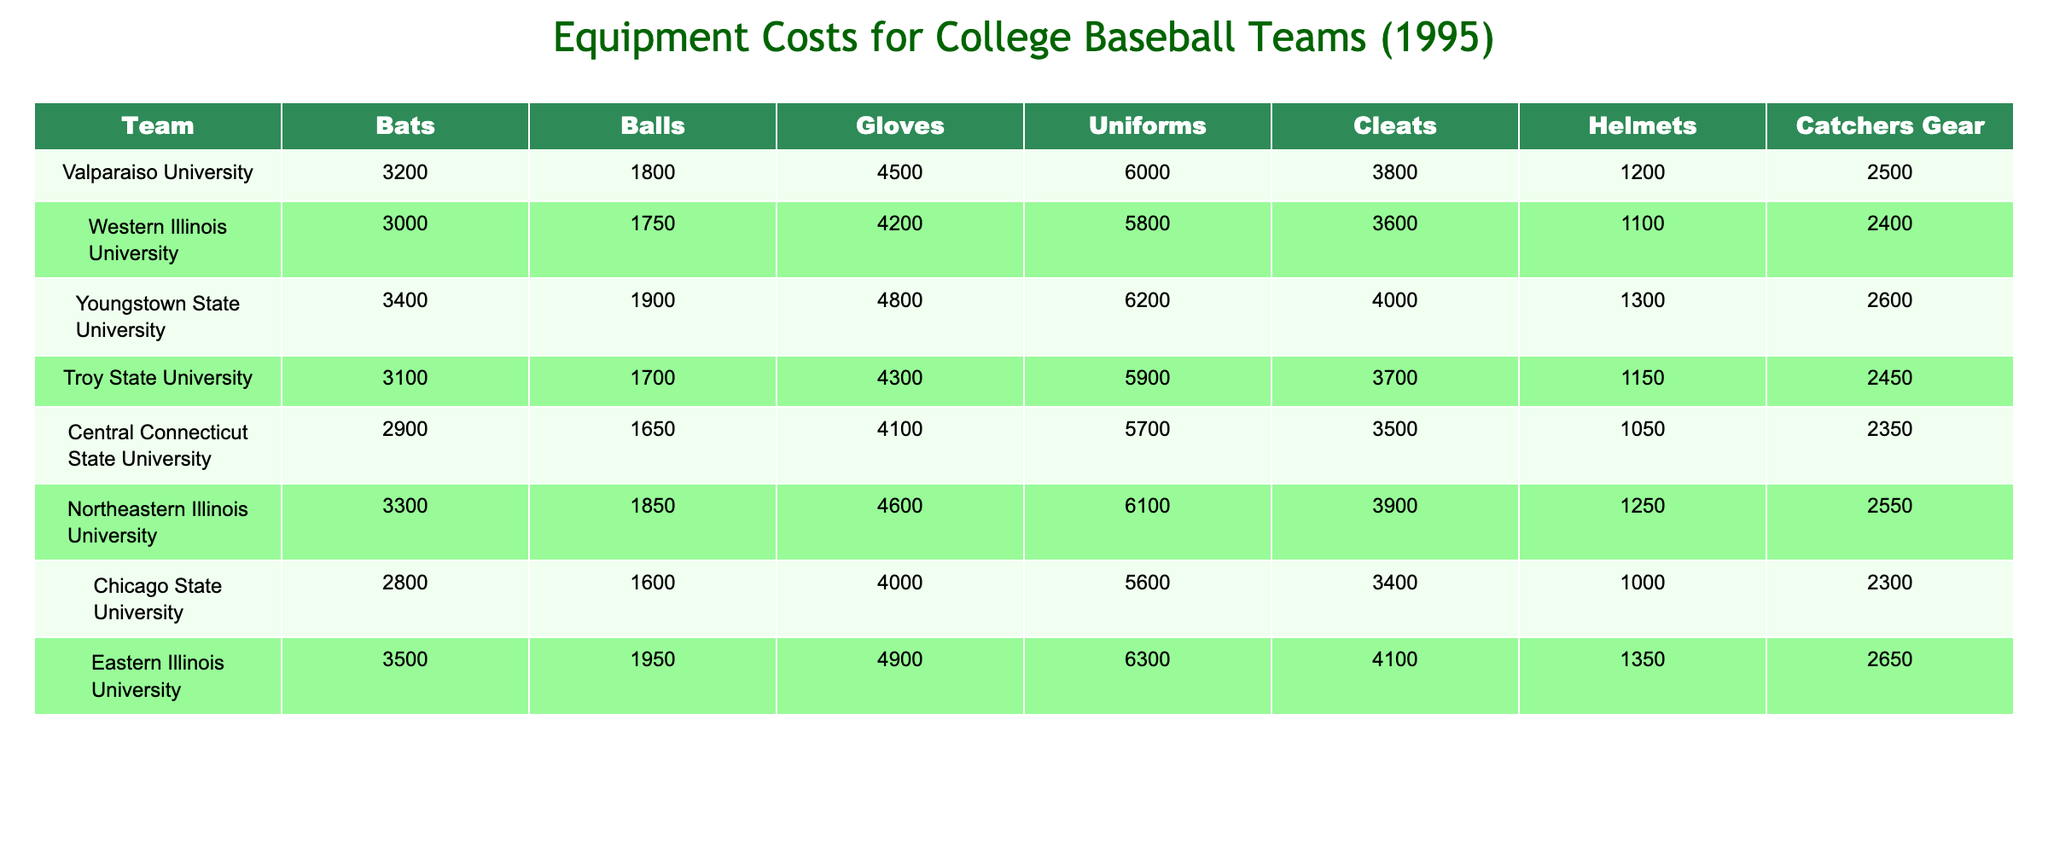What is the total cost of bats for Youngstown State University? The table shows that Youngstown State University has a cost of 3400 for bats. Therefore, the total cost of bats for this team is 3400.
Answer: 3400 Which team spent the most on uniforms? By examining the uniform costs in the table, Eastern Illinois University has the highest uniform cost of 6300 compared to all other teams.
Answer: Eastern Illinois University What is the average cost of gloves across all teams? The glove costs are: 4500, 4200, 4800, 4300, 4100, 4600, 4000, 4900. The sum is (4500 + 4200 + 4800 + 4300 + 4100 + 4600 + 4000 + 4900) = 38400. There are 8 teams, so the average is 38400/8 = 4800.
Answer: 4800 Did Chicago State University spend more on helmets than Northeastern Illinois University? Chicago State University spent 1000 on helmets, while Northeastern Illinois University spent 1250. Since 1000 is less than 1250, Chicago State University did not spend more.
Answer: No What is the total expenditure on catchers gear by the teams in the Mid-Continent Conference? The costs for catchers gear are: 2500, 2400, 2600, 2450, 2350, 2550, 2300, 2650. Adding these gives (2500 + 2400 + 2600 + 2450 + 2350 + 2550 + 2300 + 2650) = 19600.
Answer: 19600 How much more did Eastern Illinois University spend on balls compared to Central Connecticut State University? Eastern Illinois University spent 1950 on balls, while Central Connecticut State University spent 1650. The difference is 1950 - 1650 = 300.
Answer: 300 Which team had the highest total equipment costs? To find the highest total cost, we need to sum each team's costs across all categories. For instance, Valparaiso University’s total is 3200 + 1800 + 4500 + 6000 + 3800 + 1200 + 2500 = 22000. After calculating for each team, Youngstown State University has the highest total of 26800.
Answer: Youngstown State University What percentage of the total equipment cost for Valparaiso University is from cleats? Valparaiso University’s total equipment cost is 22000, and the cleat cost is 3800. The percentage is calculated as (3800 / 22000) * 100 = 17.27%.
Answer: 17.27% Which team has the lowest expenditure for balls? Looking at the balls expenditure, Chicago State University spent 1600, which is the lowest when compared to the others.
Answer: Chicago State University If you combine the costs of bats and gloves for Troy State University, what is the total? The bat cost for Troy State University is 3100 and the glove cost is 4300. Adding them gives 3100 + 4300 = 7400.
Answer: 7400 